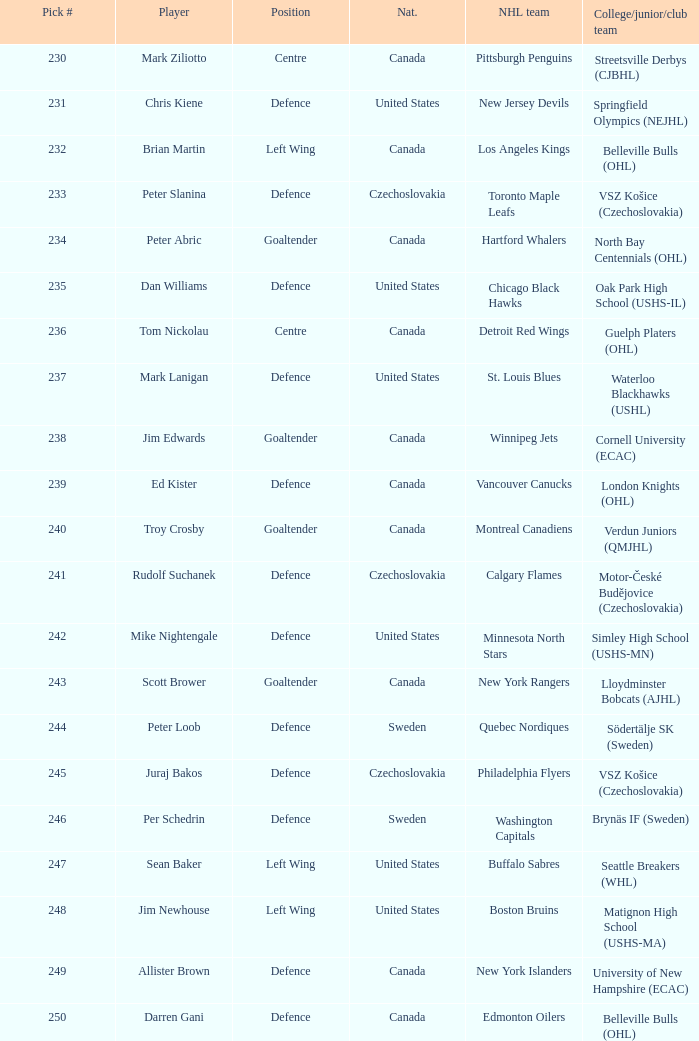List the players for team brynäs if (sweden). Per Schedrin. 